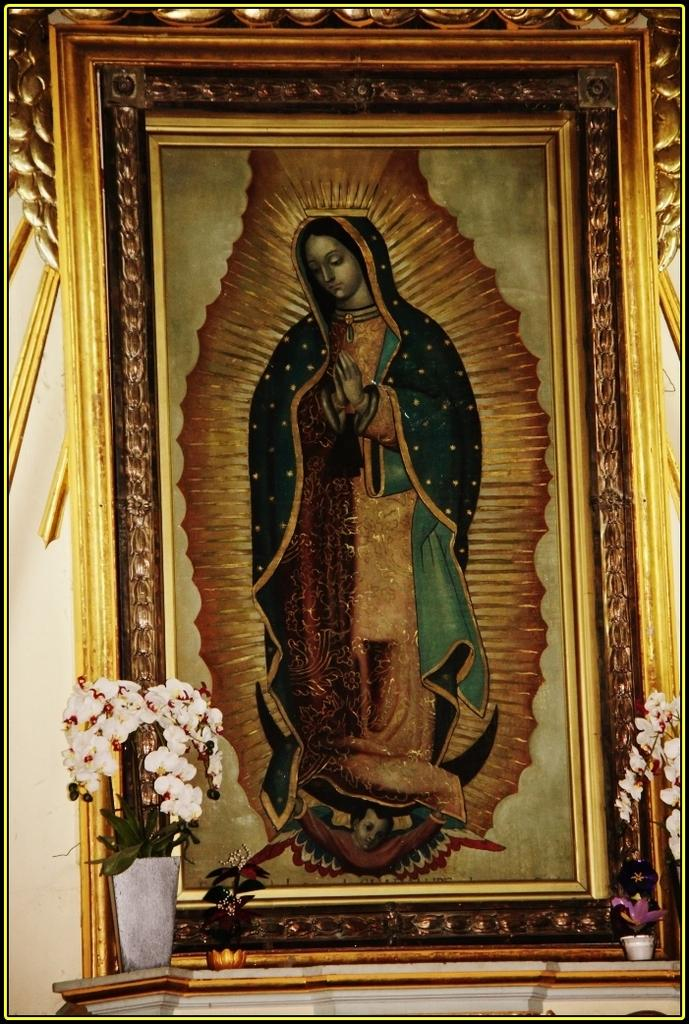What is the main object in the image? There is a frame in the image. What is depicted within the frame? The frame contains a painting of a person. Are there any additional elements associated with the frame? Yes, there are flower pots at the bottom of the frame. What type of fruit can be seen hanging from the rod in the image? There is no rod or fruit present in the image. 